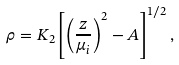Convert formula to latex. <formula><loc_0><loc_0><loc_500><loc_500>\rho = K _ { 2 } \left [ \left ( \frac { z } { \mu _ { i } } \right ) ^ { 2 } - A \right ] ^ { 1 / 2 } ,</formula> 